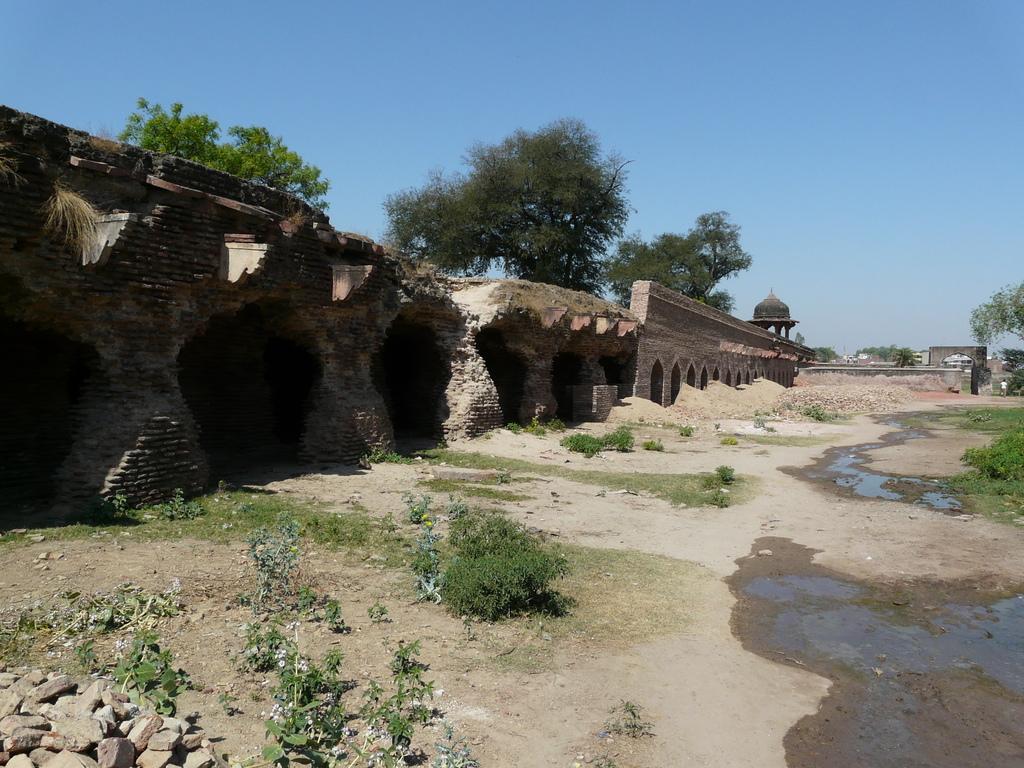Could you give a brief overview of what you see in this image? In this image there is a fort and it is damaged, there are few plants, rocks and some water on the surface. In the background there are trees and the sky. 